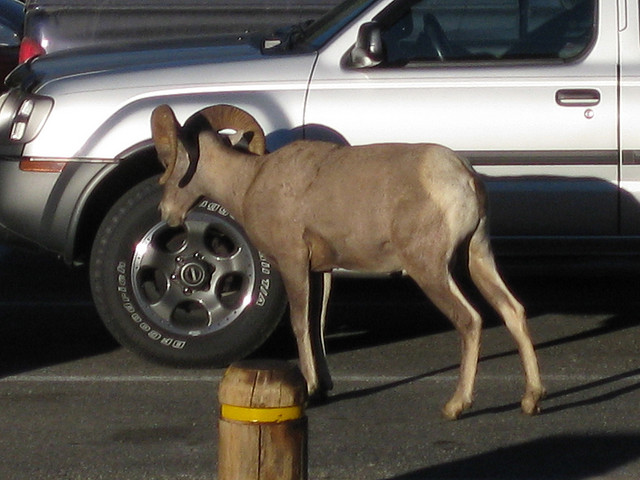What kind of animal is this? This is a donkey, identifiable by its large ears and solid build. 